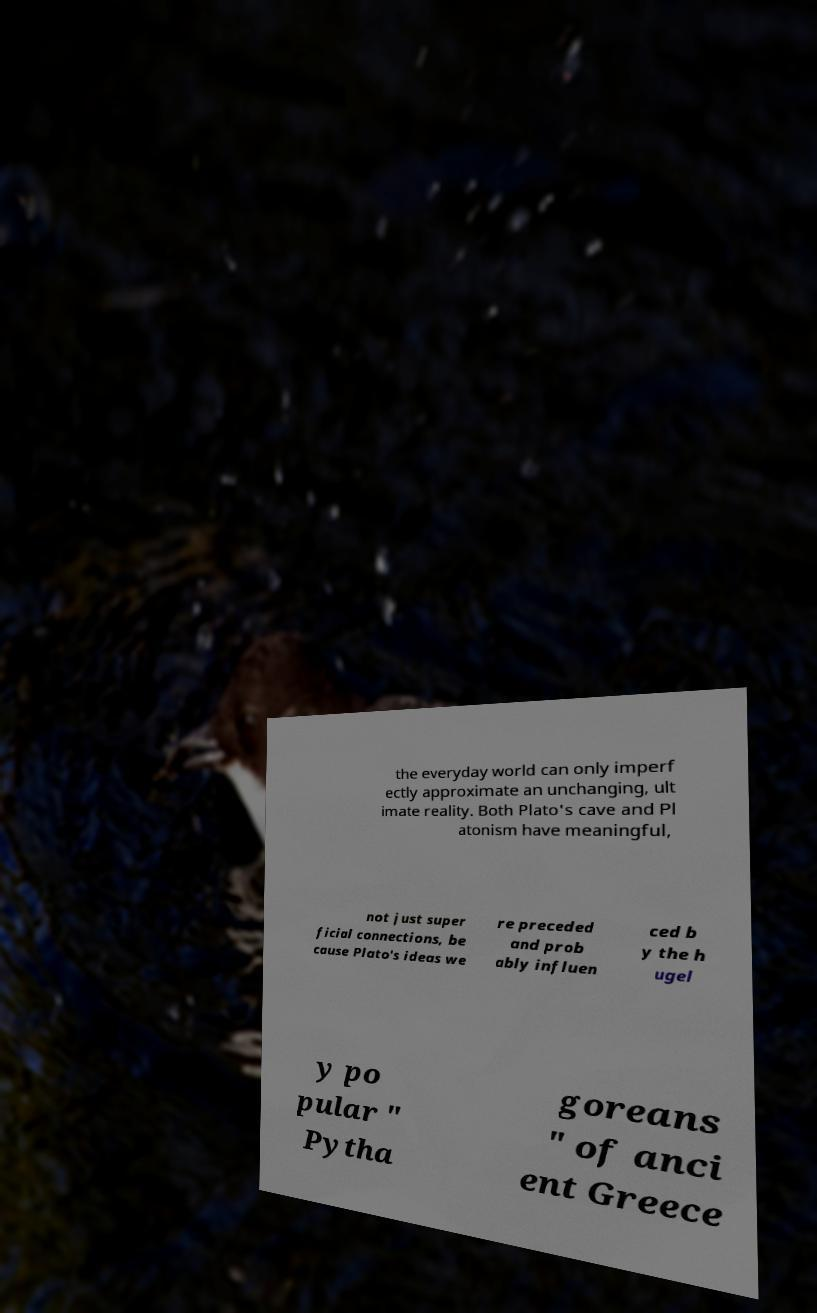Please read and relay the text visible in this image. What does it say? the everyday world can only imperf ectly approximate an unchanging, ult imate reality. Both Plato's cave and Pl atonism have meaningful, not just super ficial connections, be cause Plato's ideas we re preceded and prob ably influen ced b y the h ugel y po pular " Pytha goreans " of anci ent Greece 